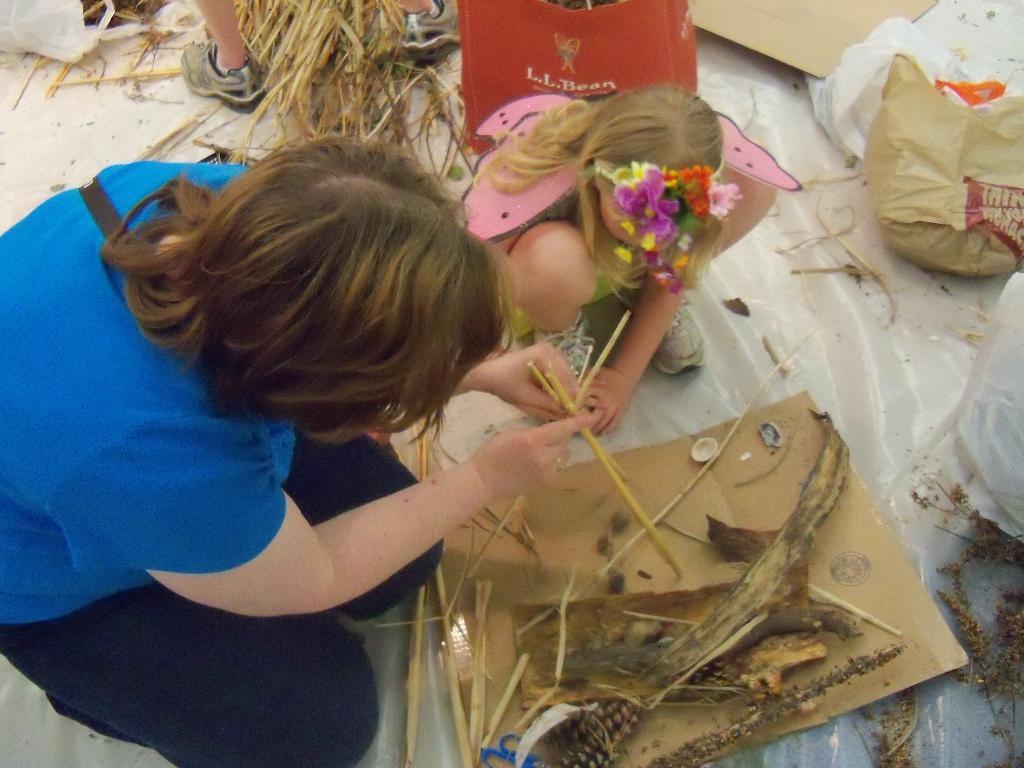Could you give a brief overview of what you see in this image? In this image there is a kid in the middle who is doing the artistic work. On the left side there is a woman who is helping the kid. In front of them there is a board on which there are sticks and dry grass. On the right side there are covers. At the top there is a red bag. Beside the bag there is dry grass in between both the legs. 